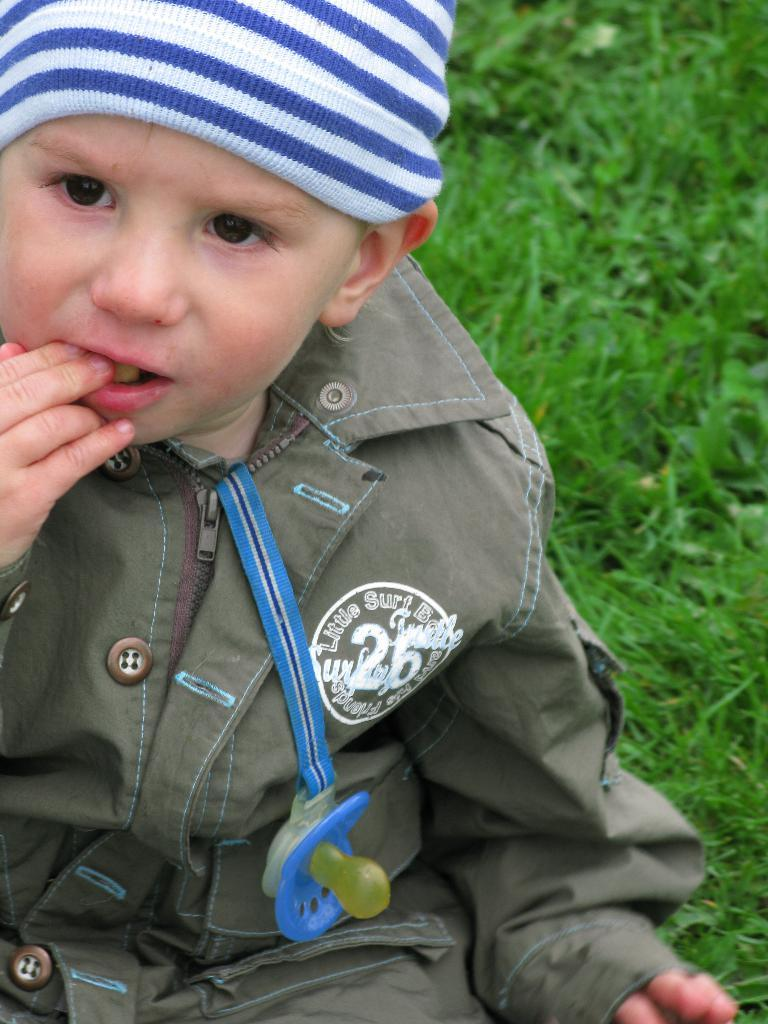What is the main subject of the image? There is a baby in the center of the image. What is the baby wearing on their head? The baby is wearing a cap. What object related to babies can be seen in the image? There is a baby sipper in the image. What type of environment is visible in the background of the image? There is grass in the background of the image. What scientific discovery was made by the baby in the image? There is no indication of a scientific discovery in the image; it simply features a baby wearing a cap and holding a baby sipper. What season is depicted in the image? The image does not specify a season, but the presence of grass in the background suggests it could be spring or summer. 